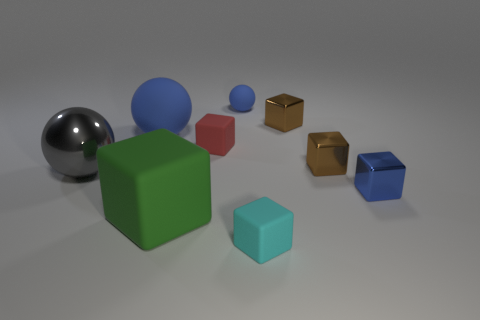There is a small thing that is the same color as the small rubber sphere; what is its shape? Beyond the small rubber sphere, we find another object sharing its jet-black hue. This object manifests itself in the distinct form of a cube, echoing the sphere's enigmatic appeal with its own geometric precision. 